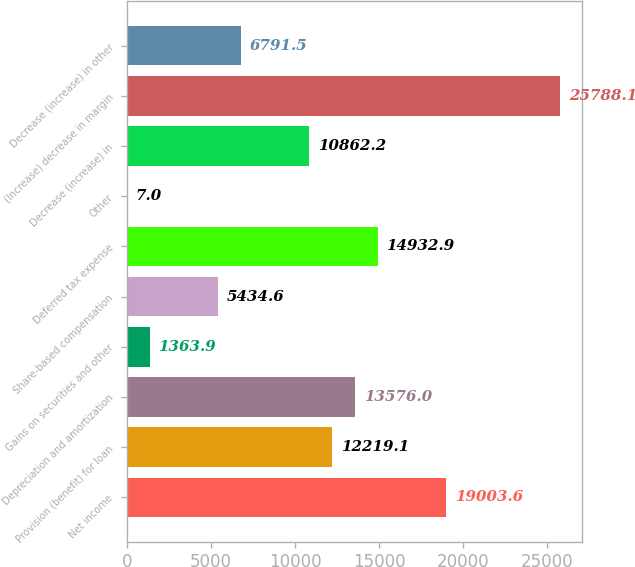Convert chart. <chart><loc_0><loc_0><loc_500><loc_500><bar_chart><fcel>Net income<fcel>Provision (benefit) for loan<fcel>Depreciation and amortization<fcel>Gains on securities and other<fcel>Share-based compensation<fcel>Deferred tax expense<fcel>Other<fcel>Decrease (increase) in<fcel>(Increase) decrease in margin<fcel>Decrease (increase) in other<nl><fcel>19003.6<fcel>12219.1<fcel>13576<fcel>1363.9<fcel>5434.6<fcel>14932.9<fcel>7<fcel>10862.2<fcel>25788.1<fcel>6791.5<nl></chart> 